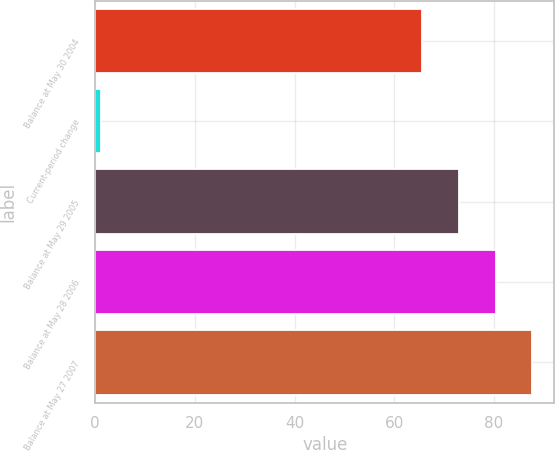Convert chart to OTSL. <chart><loc_0><loc_0><loc_500><loc_500><bar_chart><fcel>Balance at May 30 2004<fcel>Current-period change<fcel>Balance at May 29 2005<fcel>Balance at May 28 2006<fcel>Balance at May 27 2007<nl><fcel>65.6<fcel>1.2<fcel>72.96<fcel>80.32<fcel>87.68<nl></chart> 